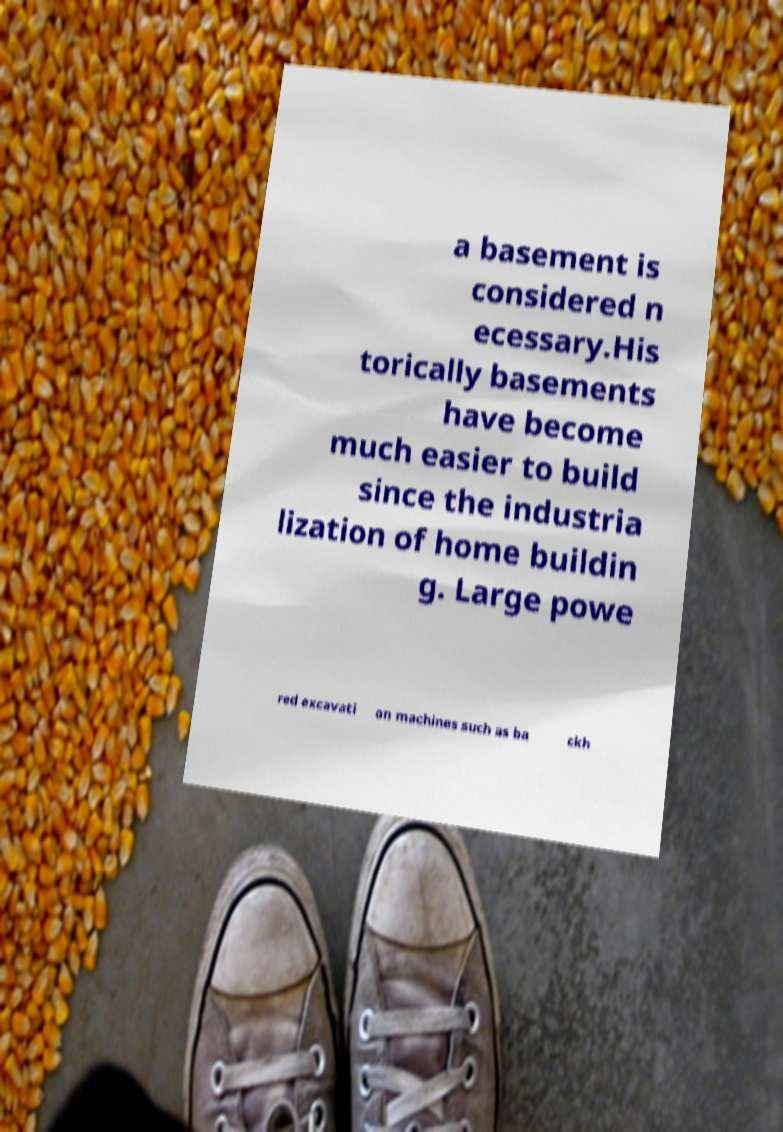For documentation purposes, I need the text within this image transcribed. Could you provide that? a basement is considered n ecessary.His torically basements have become much easier to build since the industria lization of home buildin g. Large powe red excavati on machines such as ba ckh 